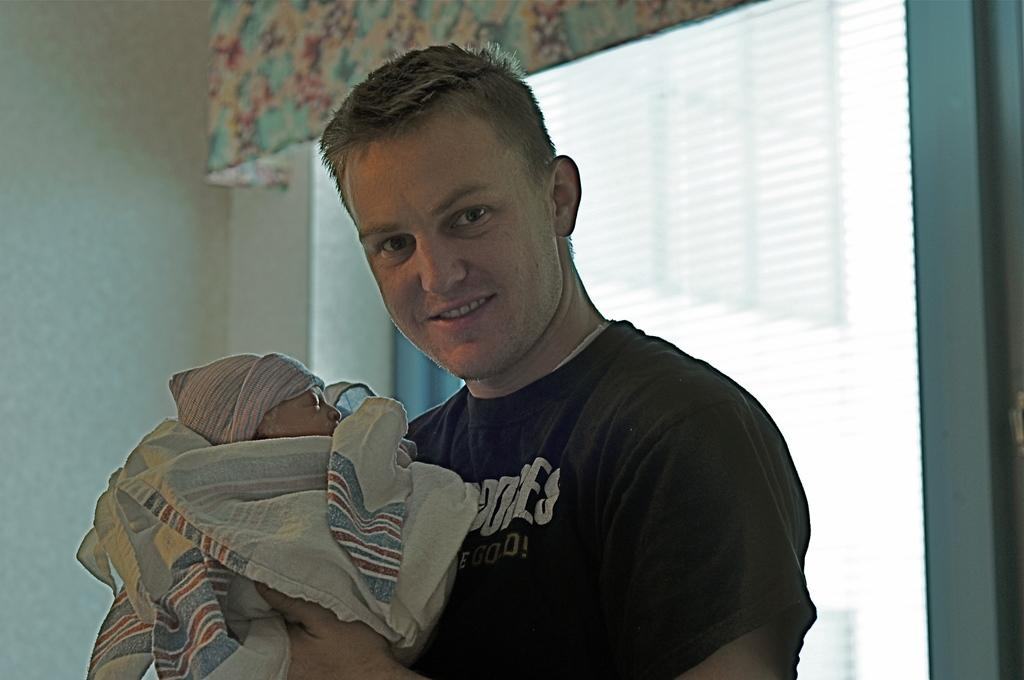What is the man in the image holding? The man is holding a baby in the image. What can be seen in the background of the image? There are blinds, a curtain, and a wall in the background of the image. What type of lettuce is visible on the man's vest in the image? There is no lettuce or vest present in the image. Can you describe the ray that is interacting with the baby in the image? There is no ray present in the image; it only features a man holding a baby and elements in the background. 